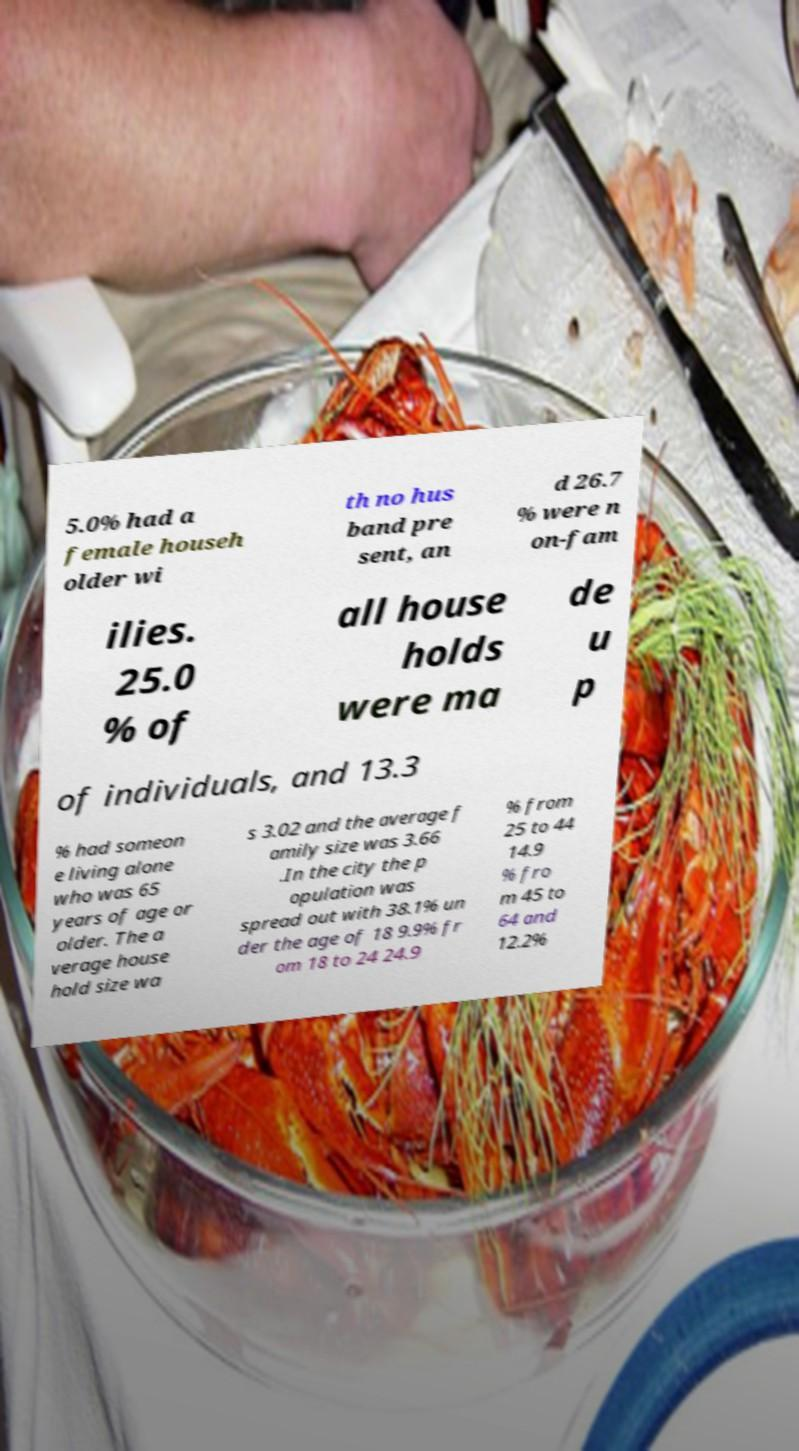Please identify and transcribe the text found in this image. 5.0% had a female househ older wi th no hus band pre sent, an d 26.7 % were n on-fam ilies. 25.0 % of all house holds were ma de u p of individuals, and 13.3 % had someon e living alone who was 65 years of age or older. The a verage house hold size wa s 3.02 and the average f amily size was 3.66 .In the city the p opulation was spread out with 38.1% un der the age of 18 9.9% fr om 18 to 24 24.9 % from 25 to 44 14.9 % fro m 45 to 64 and 12.2% 